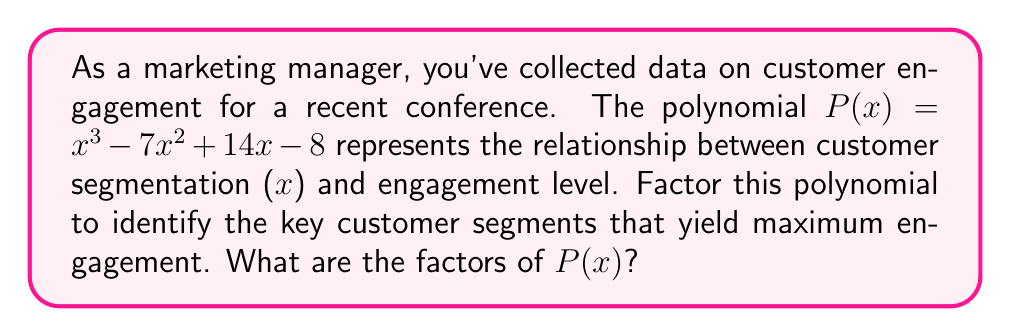Can you solve this math problem? To factor the polynomial $P(x) = x^3 - 7x^2 + 14x - 8$, we'll follow these steps:

1) First, let's check if there's a common factor. In this case, there isn't.

2) Next, we'll use the rational root theorem to find potential roots. The possible rational roots are the factors of the constant term (8): ±1, ±2, ±4, ±8.

3) Let's test these values:
   $P(1) = 1 - 7 + 14 - 8 = 0$
   We've found a root: x = 1

4) Now we can factor out $(x-1)$:
   $P(x) = (x-1)(x^2 + ax + b)$

5) Expanding this:
   $(x-1)(x^2 + ax + b) = x^3 + ax^2 + bx - x^2 - ax - b$
   $= x^3 + (a-1)x^2 + (b-a)x - b$

6) Comparing coefficients with our original polynomial:
   $a-1 = -7$, so $a = -6$
   $b-a = 14$, so $b = 8$

7) Therefore, $P(x) = (x-1)(x^2 - 6x + 8)$

8) The quadratic factor can be further factored:
   $x^2 - 6x + 8 = (x-2)(x-4)$

9) Thus, the complete factorization is:
   $P(x) = (x-1)(x-2)(x-4)$

This factorization reveals that the key customer segments correspond to x = 1, 2, and 4, which yield maximum engagement levels.
Answer: $(x-1)(x-2)(x-4)$ 